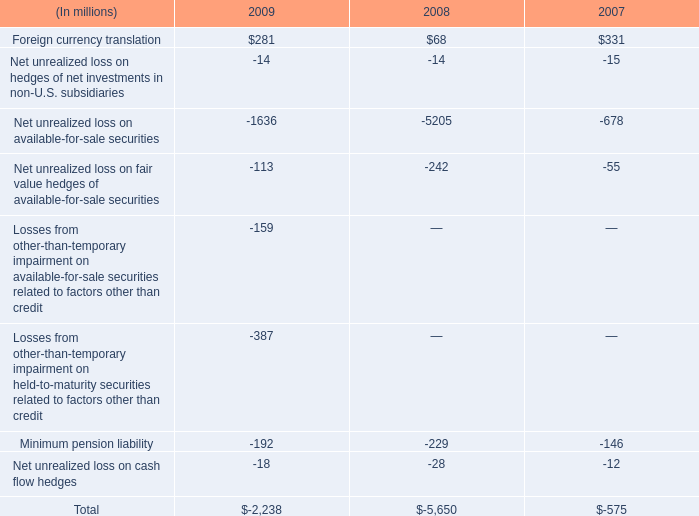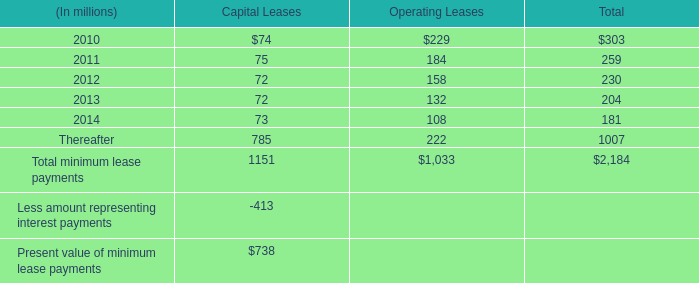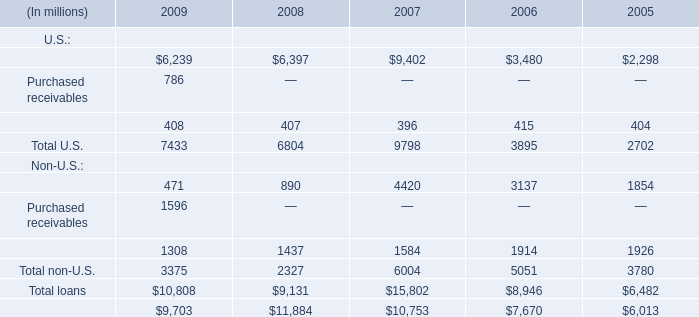Which Non-U.S. makes up more than 30% of the total in 2009? 
Computations: (3375 * 0.3)
Answer: 1012.5. 